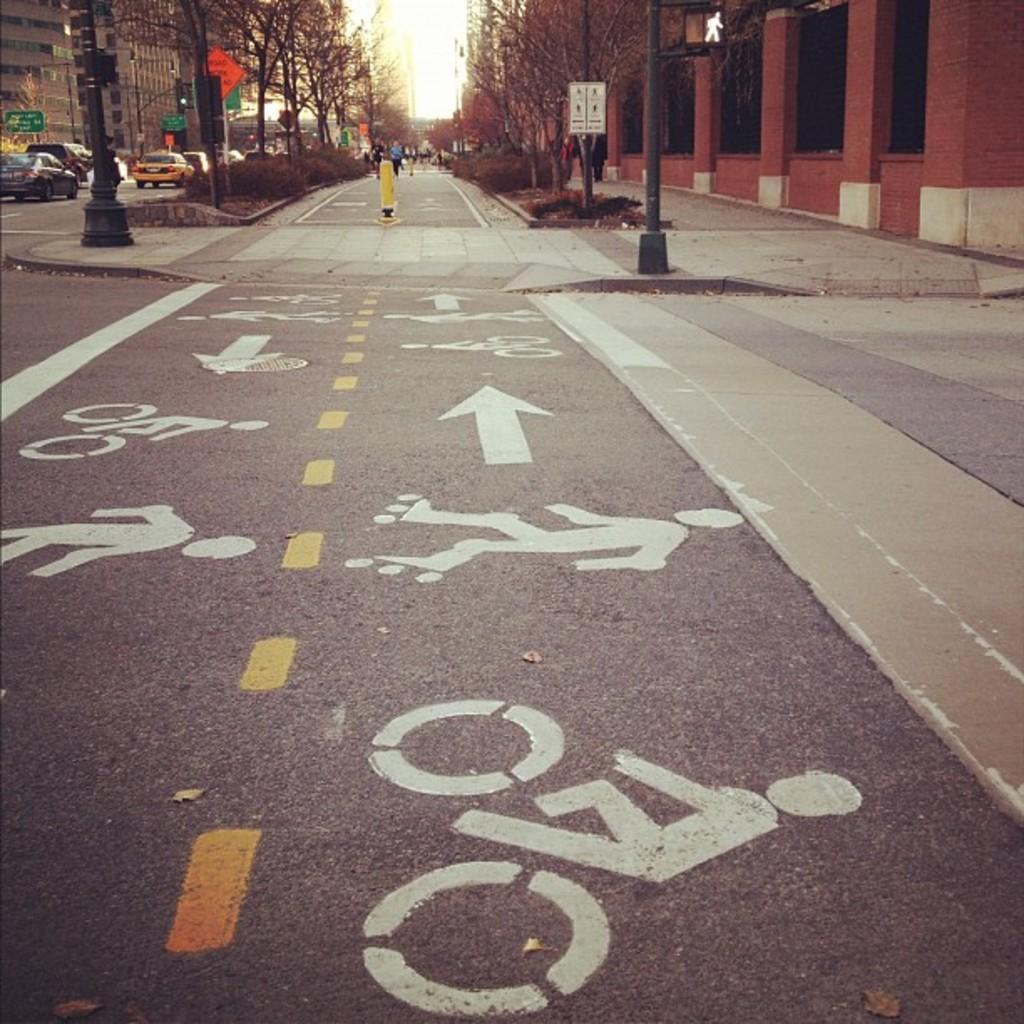In one or two sentences, can you explain what this image depicts? In the foreground of this image, in the middle, there is a road. On either side, there are plants, trees, buildings, poles and the boards. On the right, there is a pavement. On the left, there are vehicles moving on the road. In the background, there is the sky. 